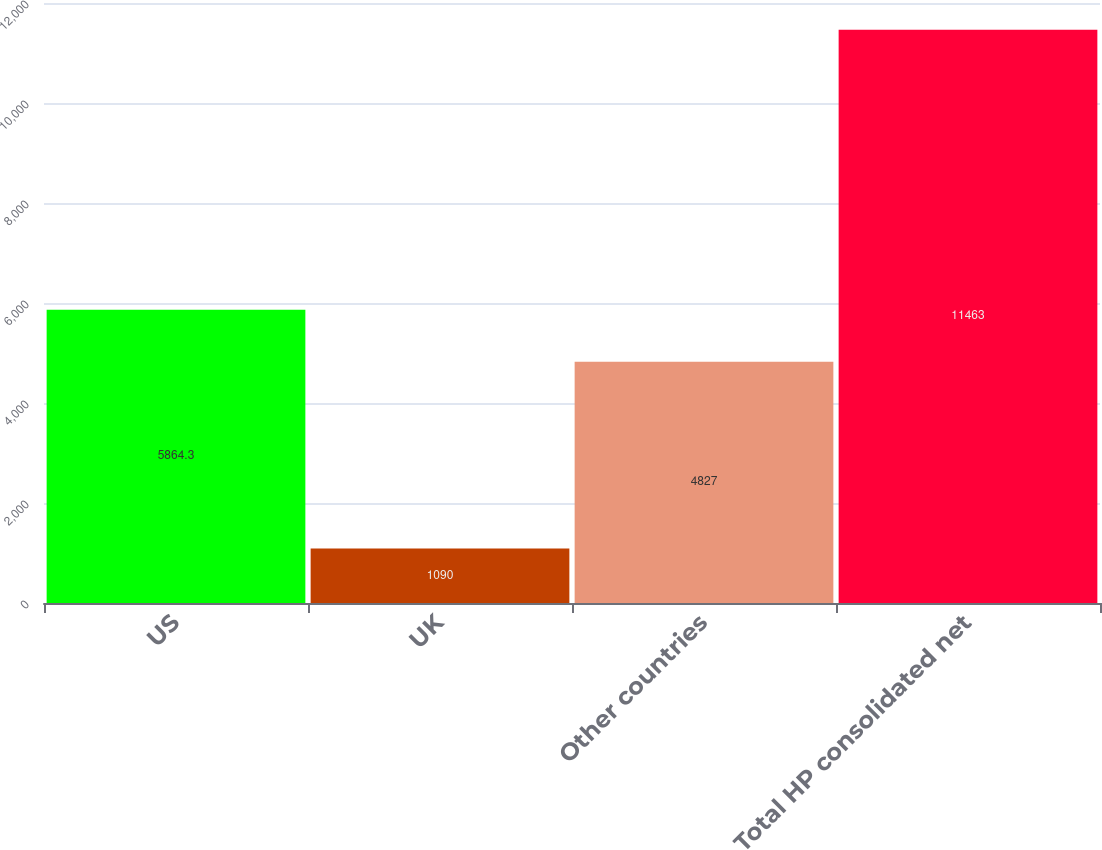Convert chart. <chart><loc_0><loc_0><loc_500><loc_500><bar_chart><fcel>US<fcel>UK<fcel>Other countries<fcel>Total HP consolidated net<nl><fcel>5864.3<fcel>1090<fcel>4827<fcel>11463<nl></chart> 